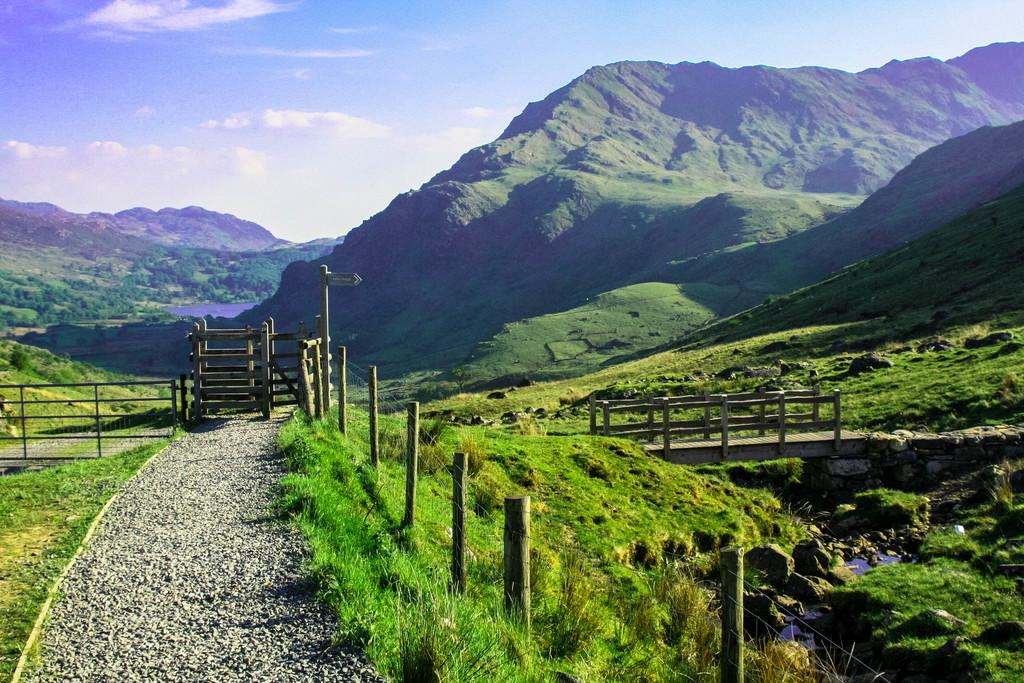What can be seen on the left side of the image? There is a road on the left side of the image. What is located on the right side of the image? There is a bridge on the right side of the image. What type of natural formation is in the middle of the image? There are mountains in the middle of the image. What is visible in the background of the image? Clouds and the sky are visible in the background of the image. How many pizzas are being carried by the bears in the image? There are no bears or pizzas present in the image. What sound does the whistle make in the image? There is no whistle present in the image. 